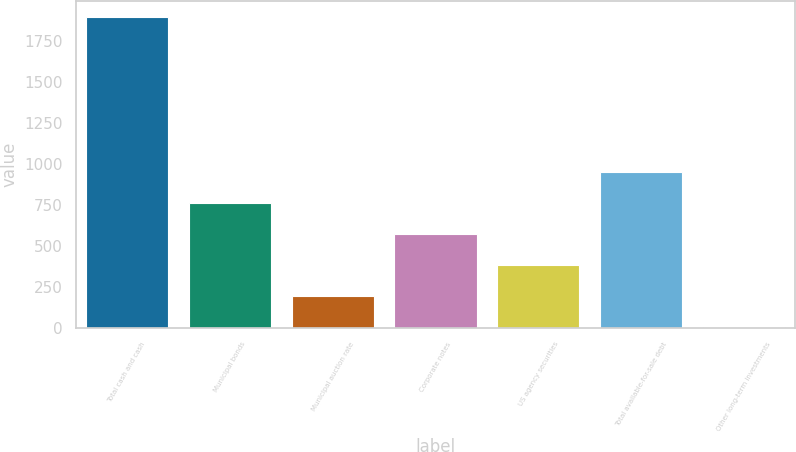Convert chart to OTSL. <chart><loc_0><loc_0><loc_500><loc_500><bar_chart><fcel>Total cash and cash<fcel>Municipal bonds<fcel>Municipal auction rate<fcel>Corporate notes<fcel>US agency securities<fcel>Total available-for-sale debt<fcel>Other long-term investments<nl><fcel>1898<fcel>761.6<fcel>193.4<fcel>572.2<fcel>382.8<fcel>951<fcel>4<nl></chart> 